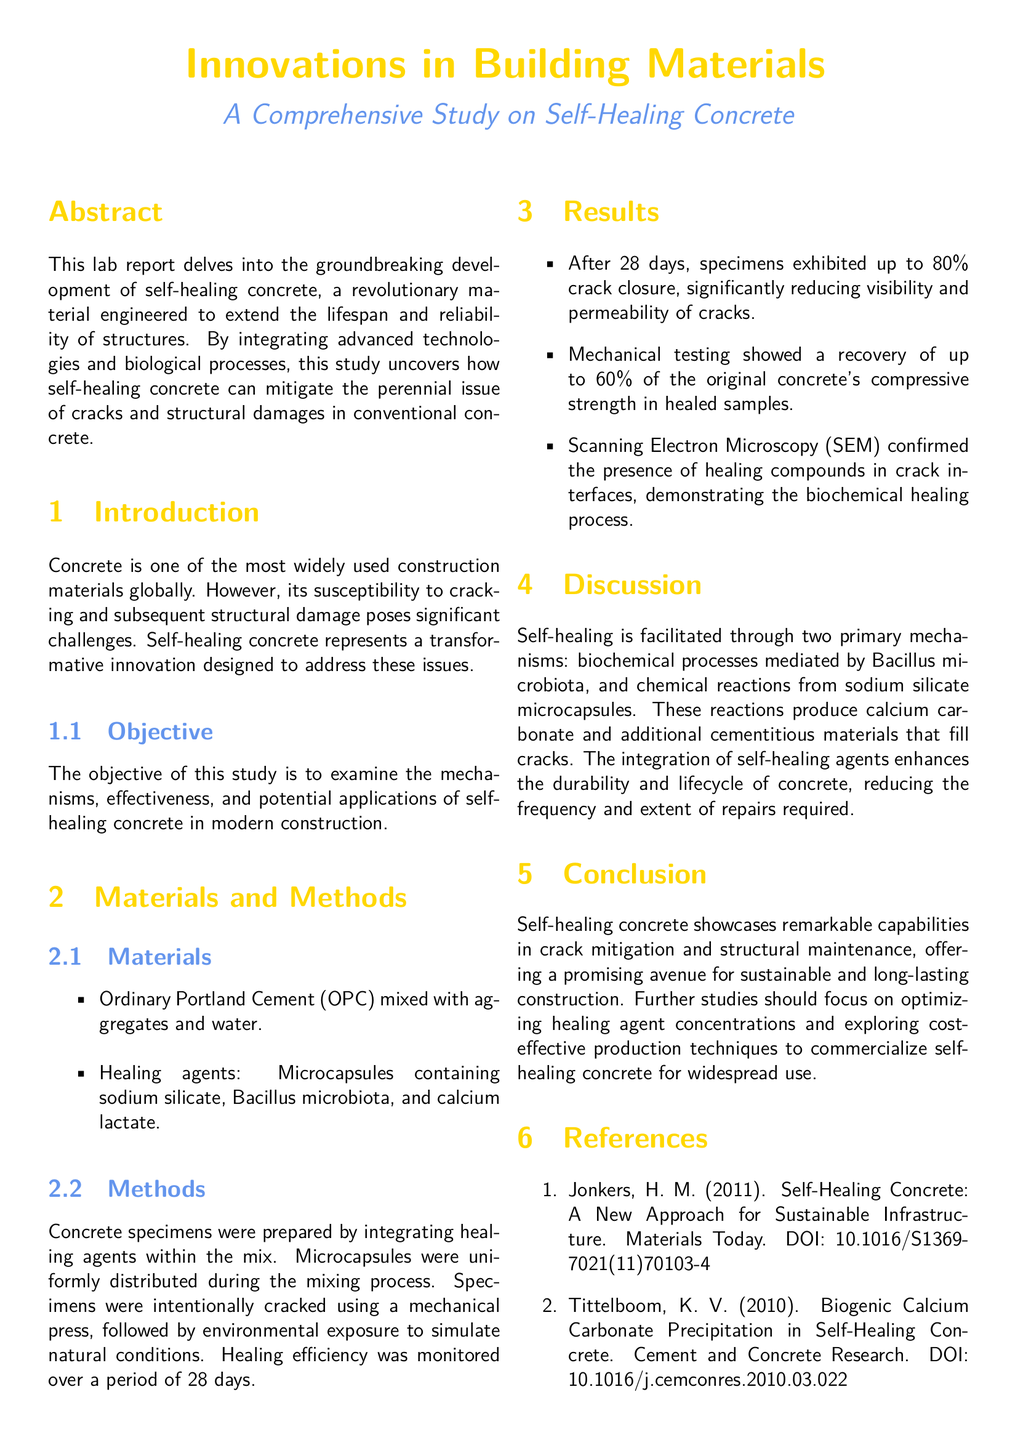What is the main subject of the study? The study focuses on a specific type of innovative building material, which is indicated in the title and abstract.
Answer: Self-healing concrete What healing agents were used in the study? The healing agents mentioned in the Materials section provide insight into what was blended into the concrete mix.
Answer: Microcapsules containing sodium silicate, Bacillus microbiota, and calcium lactate What was the maximum percentage of crack closure achieved? This information can be found in the Results section, which details the outcomes of the experiment.
Answer: 80% What recovery of original compressive strength was observed in healed samples? The Results section includes specific numerical data regarding the mechanical testing of healed samples.
Answer: 60% What are the two primary mechanisms facilitating self-healing? The Discussion section lists and summarizes these mechanisms, providing a concise understanding of how self-healing occurs.
Answer: Biochemical processes and chemical reactions What period was used to monitor healing efficiency? The Methods section states the duration over which the healing efficiency was observed.
Answer: 28 days Who authored the first reference in the document? The References section provides author information tied to each referenced work.
Answer: Jonkers What type of document is this? The structure and content of the document suggest its classification, which can be directly inferred from its title.
Answer: Lab report What is the primary objective of the study? The objective is outlined clearly in the Introduction section, summarizing the intent behind the research.
Answer: To examine the mechanisms, effectiveness, and potential applications of self-healing concrete 